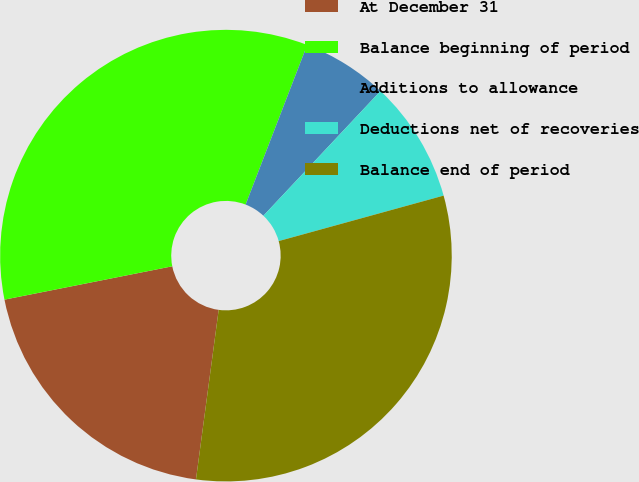<chart> <loc_0><loc_0><loc_500><loc_500><pie_chart><fcel>At December 31<fcel>Balance beginning of period<fcel>Additions to allowance<fcel>Deductions net of recoveries<fcel>Balance end of period<nl><fcel>19.76%<fcel>33.98%<fcel>6.14%<fcel>8.72%<fcel>31.4%<nl></chart> 